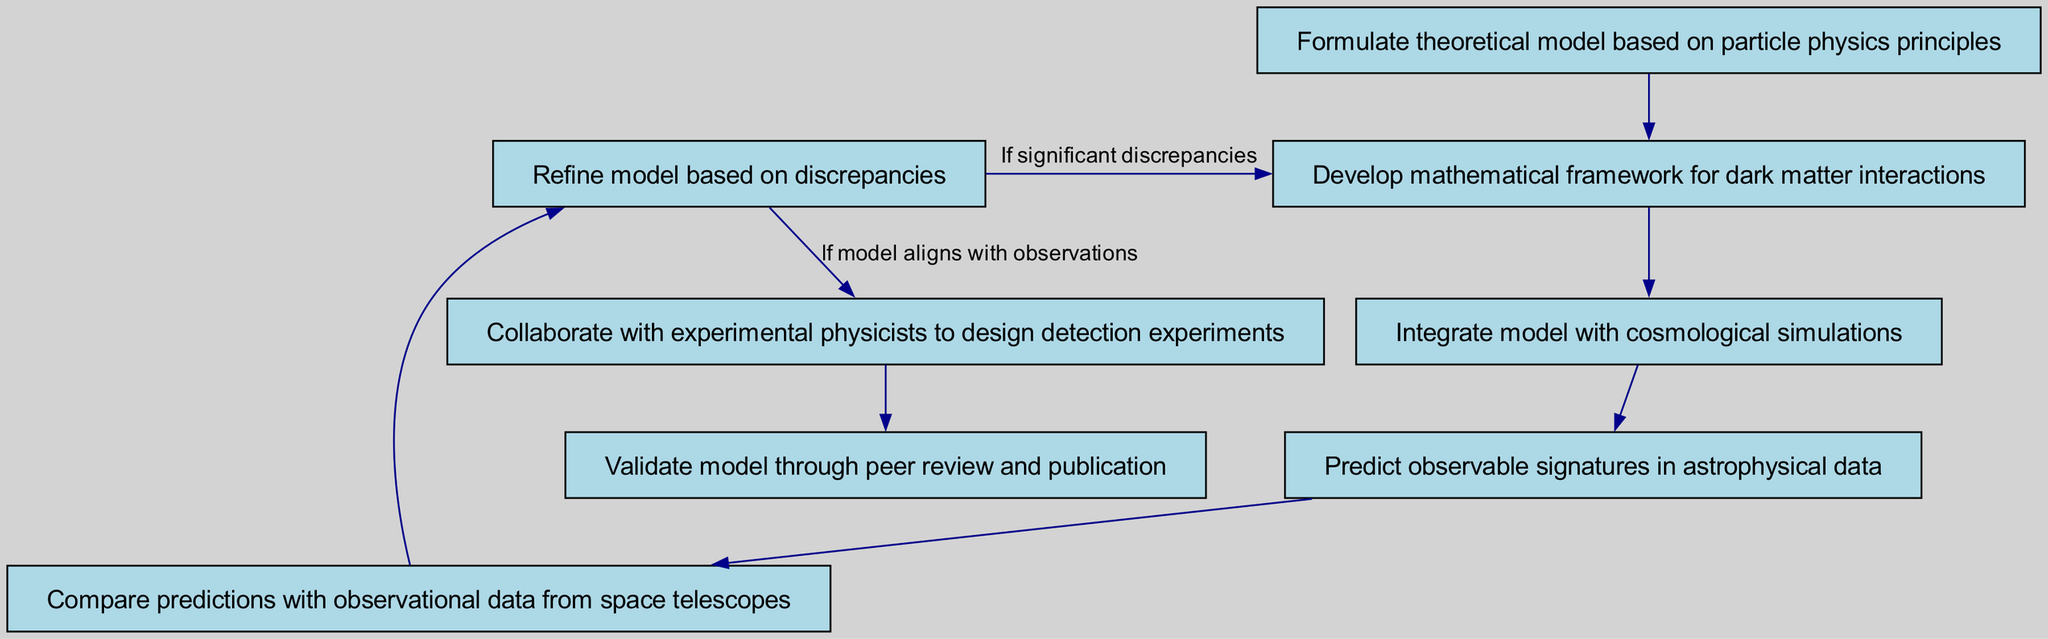What is the first step in the diagram? The first step in the diagram is represented by the node with id "1", which states "Formulate theoretical model based on particle physics principles". Thus, this is the initial action to begin the process.
Answer: Formulate theoretical model based on particle physics principles How many nodes are there in the diagram? The diagram contains a total of 8 nodes, each representing a step in the process of developing and validating theoretical models of dark matter interactions.
Answer: 8 What is the last step in the diagram? The last step is indicated by node "8", which reads "Validate model through peer review and publication", marking the end of the flow.
Answer: Validate model through peer review and publication Which step follows developing a mathematical framework for dark matter interactions? Following the step of developing a mathematical framework, which is node "2", the next step is node "3", where it states "Integrate model with cosmological simulations". This shows the sequence of actions in the process.
Answer: Integrate model with cosmological simulations What happens if significant discrepancies are found? If significant discrepancies are identified, the flow leads back to step "2" to "Develop mathematical framework for dark matter interactions", indicating that the model will need to be revisited and refined.
Answer: Develop mathematical framework for dark matter interactions Which two steps are connected by a feedback loop? The feedback loop connects node "2" with node "6", indicating that if discrepancies arise, the process will cycle back to refining the mathematical framework based on the outcomes of discrepancies identified in the model.
Answer: Develop mathematical framework for dark matter interactions, Refine model based on discrepancies How many direct relationships lead to the "Validate model through peer review and publication"? There is one direct relationship that leads to the final step of validating the model, which comes from the previous node "7", indicating the collaborative efforts made with experimental physicists.
Answer: 1 What is the purpose of collaborating with experimental physicists in the diagram? The collaboration with experimental physicists, represented by node "7", aims to design detection experiments that will help confirm the theoretical model developed. This is an important step in linking theory to practical application.
Answer: Design detection experiments 